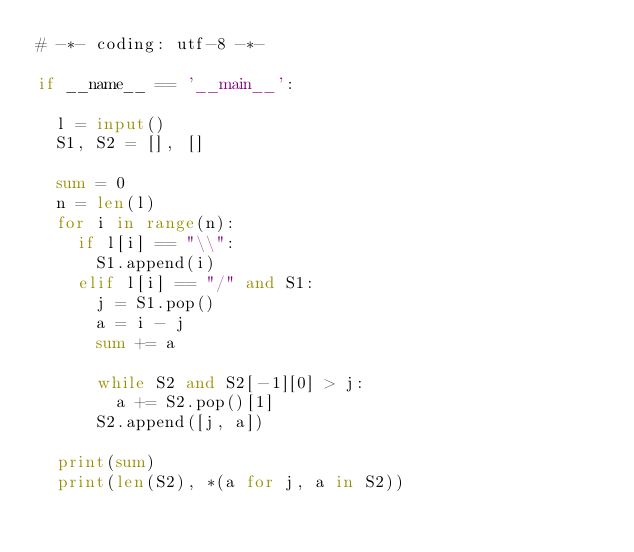<code> <loc_0><loc_0><loc_500><loc_500><_Python_># -*- coding: utf-8 -*-

if __name__ == '__main__':

	l = input()
	S1, S2 = [], []
	
	sum = 0
	n = len(l)
	for i in range(n):
		if l[i] == "\\":
			S1.append(i)
		elif l[i] == "/" and S1:
			j = S1.pop()
			a = i - j
			sum += a
	
			while S2 and S2[-1][0] > j:
				a += S2.pop()[1]
			S2.append([j, a])
	
	print(sum)
	print(len(S2), *(a for j, a in S2))</code> 